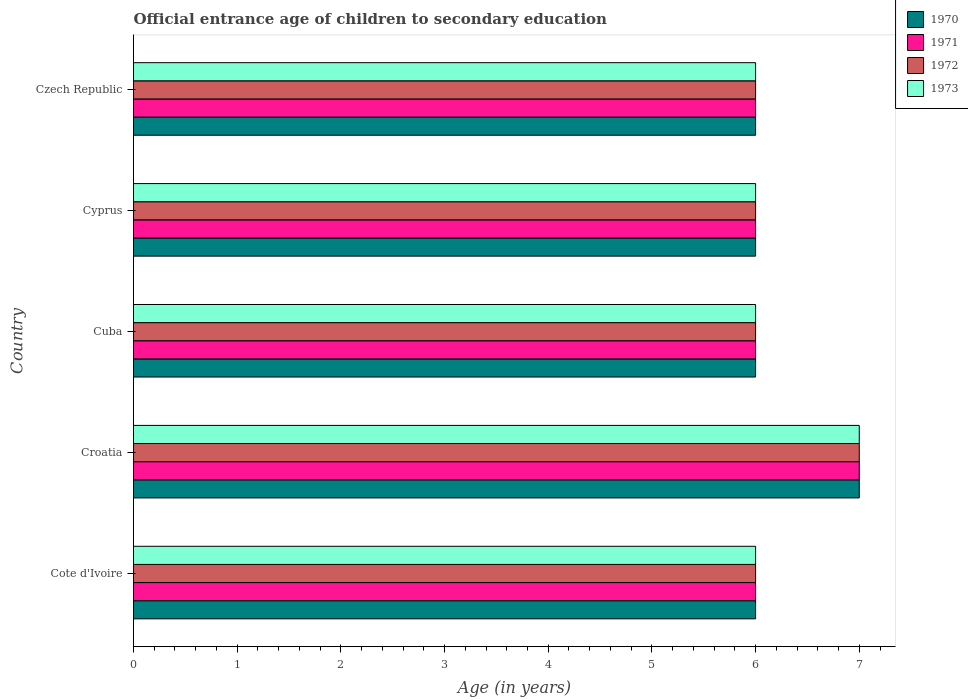Are the number of bars per tick equal to the number of legend labels?
Provide a short and direct response. Yes. Are the number of bars on each tick of the Y-axis equal?
Keep it short and to the point. Yes. What is the label of the 4th group of bars from the top?
Give a very brief answer. Croatia. Across all countries, what is the maximum secondary school starting age of children in 1970?
Provide a short and direct response. 7. In which country was the secondary school starting age of children in 1970 maximum?
Ensure brevity in your answer.  Croatia. In which country was the secondary school starting age of children in 1972 minimum?
Give a very brief answer. Cote d'Ivoire. What is the difference between the secondary school starting age of children in 1973 and secondary school starting age of children in 1971 in Cote d'Ivoire?
Your answer should be very brief. 0. In how many countries, is the secondary school starting age of children in 1972 greater than 1.4 years?
Make the answer very short. 5. What is the ratio of the secondary school starting age of children in 1971 in Cuba to that in Cyprus?
Keep it short and to the point. 1. Is the difference between the secondary school starting age of children in 1973 in Cote d'Ivoire and Croatia greater than the difference between the secondary school starting age of children in 1971 in Cote d'Ivoire and Croatia?
Make the answer very short. No. In how many countries, is the secondary school starting age of children in 1970 greater than the average secondary school starting age of children in 1970 taken over all countries?
Ensure brevity in your answer.  1. Is it the case that in every country, the sum of the secondary school starting age of children in 1973 and secondary school starting age of children in 1970 is greater than the sum of secondary school starting age of children in 1971 and secondary school starting age of children in 1972?
Offer a terse response. No. How many bars are there?
Keep it short and to the point. 20. Are all the bars in the graph horizontal?
Offer a very short reply. Yes. How many countries are there in the graph?
Your answer should be very brief. 5. Are the values on the major ticks of X-axis written in scientific E-notation?
Your answer should be very brief. No. Does the graph contain grids?
Ensure brevity in your answer.  No. How are the legend labels stacked?
Give a very brief answer. Vertical. What is the title of the graph?
Make the answer very short. Official entrance age of children to secondary education. Does "2002" appear as one of the legend labels in the graph?
Keep it short and to the point. No. What is the label or title of the X-axis?
Keep it short and to the point. Age (in years). What is the label or title of the Y-axis?
Your response must be concise. Country. What is the Age (in years) of 1972 in Cote d'Ivoire?
Ensure brevity in your answer.  6. What is the Age (in years) of 1973 in Cote d'Ivoire?
Offer a terse response. 6. What is the Age (in years) of 1970 in Cuba?
Your answer should be compact. 6. What is the Age (in years) in 1971 in Cuba?
Your answer should be very brief. 6. What is the Age (in years) in 1972 in Cuba?
Your answer should be very brief. 6. What is the Age (in years) in 1972 in Cyprus?
Offer a terse response. 6. Across all countries, what is the maximum Age (in years) of 1972?
Provide a succinct answer. 7. Across all countries, what is the minimum Age (in years) of 1972?
Provide a succinct answer. 6. Across all countries, what is the minimum Age (in years) in 1973?
Make the answer very short. 6. What is the total Age (in years) of 1970 in the graph?
Keep it short and to the point. 31. What is the total Age (in years) of 1972 in the graph?
Your response must be concise. 31. What is the total Age (in years) of 1973 in the graph?
Provide a succinct answer. 31. What is the difference between the Age (in years) of 1970 in Cote d'Ivoire and that in Croatia?
Your response must be concise. -1. What is the difference between the Age (in years) in 1971 in Cote d'Ivoire and that in Croatia?
Offer a terse response. -1. What is the difference between the Age (in years) in 1970 in Cote d'Ivoire and that in Cuba?
Provide a short and direct response. 0. What is the difference between the Age (in years) in 1973 in Cote d'Ivoire and that in Cuba?
Keep it short and to the point. 0. What is the difference between the Age (in years) in 1970 in Cote d'Ivoire and that in Cyprus?
Make the answer very short. 0. What is the difference between the Age (in years) in 1971 in Cote d'Ivoire and that in Cyprus?
Make the answer very short. 0. What is the difference between the Age (in years) in 1972 in Cote d'Ivoire and that in Cyprus?
Make the answer very short. 0. What is the difference between the Age (in years) of 1970 in Cote d'Ivoire and that in Czech Republic?
Offer a terse response. 0. What is the difference between the Age (in years) in 1973 in Cote d'Ivoire and that in Czech Republic?
Your answer should be compact. 0. What is the difference between the Age (in years) of 1973 in Croatia and that in Cuba?
Give a very brief answer. 1. What is the difference between the Age (in years) in 1970 in Croatia and that in Cyprus?
Your answer should be compact. 1. What is the difference between the Age (in years) of 1972 in Croatia and that in Cyprus?
Your answer should be compact. 1. What is the difference between the Age (in years) in 1973 in Croatia and that in Cyprus?
Ensure brevity in your answer.  1. What is the difference between the Age (in years) of 1972 in Croatia and that in Czech Republic?
Provide a succinct answer. 1. What is the difference between the Age (in years) of 1972 in Cuba and that in Cyprus?
Offer a terse response. 0. What is the difference between the Age (in years) in 1970 in Cuba and that in Czech Republic?
Offer a very short reply. 0. What is the difference between the Age (in years) of 1971 in Cuba and that in Czech Republic?
Give a very brief answer. 0. What is the difference between the Age (in years) in 1973 in Cuba and that in Czech Republic?
Provide a short and direct response. 0. What is the difference between the Age (in years) in 1972 in Cyprus and that in Czech Republic?
Keep it short and to the point. 0. What is the difference between the Age (in years) in 1973 in Cyprus and that in Czech Republic?
Offer a terse response. 0. What is the difference between the Age (in years) of 1970 in Cote d'Ivoire and the Age (in years) of 1972 in Croatia?
Provide a short and direct response. -1. What is the difference between the Age (in years) in 1970 in Cote d'Ivoire and the Age (in years) in 1971 in Cuba?
Offer a terse response. 0. What is the difference between the Age (in years) of 1971 in Cote d'Ivoire and the Age (in years) of 1972 in Cuba?
Your answer should be compact. 0. What is the difference between the Age (in years) in 1972 in Cote d'Ivoire and the Age (in years) in 1973 in Cuba?
Your answer should be compact. 0. What is the difference between the Age (in years) of 1970 in Cote d'Ivoire and the Age (in years) of 1972 in Cyprus?
Offer a very short reply. 0. What is the difference between the Age (in years) in 1970 in Cote d'Ivoire and the Age (in years) in 1973 in Cyprus?
Your response must be concise. 0. What is the difference between the Age (in years) of 1971 in Cote d'Ivoire and the Age (in years) of 1973 in Cyprus?
Give a very brief answer. 0. What is the difference between the Age (in years) in 1972 in Cote d'Ivoire and the Age (in years) in 1973 in Cyprus?
Offer a very short reply. 0. What is the difference between the Age (in years) in 1972 in Cote d'Ivoire and the Age (in years) in 1973 in Czech Republic?
Offer a very short reply. 0. What is the difference between the Age (in years) in 1971 in Croatia and the Age (in years) in 1973 in Cuba?
Your answer should be very brief. 1. What is the difference between the Age (in years) of 1972 in Croatia and the Age (in years) of 1973 in Cuba?
Your response must be concise. 1. What is the difference between the Age (in years) of 1971 in Croatia and the Age (in years) of 1972 in Cyprus?
Give a very brief answer. 1. What is the difference between the Age (in years) in 1972 in Croatia and the Age (in years) in 1973 in Cyprus?
Keep it short and to the point. 1. What is the difference between the Age (in years) in 1970 in Croatia and the Age (in years) in 1971 in Czech Republic?
Give a very brief answer. 1. What is the difference between the Age (in years) in 1970 in Croatia and the Age (in years) in 1972 in Czech Republic?
Keep it short and to the point. 1. What is the difference between the Age (in years) of 1970 in Croatia and the Age (in years) of 1973 in Czech Republic?
Offer a very short reply. 1. What is the difference between the Age (in years) of 1971 in Croatia and the Age (in years) of 1972 in Czech Republic?
Keep it short and to the point. 1. What is the difference between the Age (in years) of 1970 in Cuba and the Age (in years) of 1972 in Cyprus?
Your answer should be compact. 0. What is the difference between the Age (in years) of 1970 in Cuba and the Age (in years) of 1973 in Cyprus?
Your answer should be compact. 0. What is the difference between the Age (in years) in 1971 in Cuba and the Age (in years) in 1972 in Cyprus?
Make the answer very short. 0. What is the difference between the Age (in years) of 1971 in Cuba and the Age (in years) of 1973 in Cyprus?
Ensure brevity in your answer.  0. What is the difference between the Age (in years) of 1972 in Cuba and the Age (in years) of 1973 in Cyprus?
Your answer should be very brief. 0. What is the difference between the Age (in years) of 1970 in Cuba and the Age (in years) of 1971 in Czech Republic?
Give a very brief answer. 0. What is the difference between the Age (in years) of 1971 in Cuba and the Age (in years) of 1973 in Czech Republic?
Provide a short and direct response. 0. What is the difference between the Age (in years) of 1972 in Cuba and the Age (in years) of 1973 in Czech Republic?
Keep it short and to the point. 0. What is the difference between the Age (in years) in 1970 in Cyprus and the Age (in years) in 1972 in Czech Republic?
Your answer should be very brief. 0. What is the difference between the Age (in years) in 1970 in Cyprus and the Age (in years) in 1973 in Czech Republic?
Give a very brief answer. 0. What is the difference between the Age (in years) in 1971 in Cyprus and the Age (in years) in 1972 in Czech Republic?
Provide a succinct answer. 0. What is the average Age (in years) in 1971 per country?
Ensure brevity in your answer.  6.2. What is the difference between the Age (in years) in 1970 and Age (in years) in 1973 in Cote d'Ivoire?
Give a very brief answer. 0. What is the difference between the Age (in years) in 1971 and Age (in years) in 1972 in Cote d'Ivoire?
Offer a terse response. 0. What is the difference between the Age (in years) of 1972 and Age (in years) of 1973 in Cote d'Ivoire?
Your answer should be very brief. 0. What is the difference between the Age (in years) of 1970 and Age (in years) of 1972 in Croatia?
Offer a very short reply. 0. What is the difference between the Age (in years) in 1971 and Age (in years) in 1973 in Croatia?
Ensure brevity in your answer.  0. What is the difference between the Age (in years) of 1970 and Age (in years) of 1972 in Cuba?
Your answer should be compact. 0. What is the difference between the Age (in years) of 1971 and Age (in years) of 1972 in Cuba?
Offer a very short reply. 0. What is the difference between the Age (in years) of 1971 and Age (in years) of 1973 in Cuba?
Provide a short and direct response. 0. What is the difference between the Age (in years) in 1970 and Age (in years) in 1972 in Cyprus?
Your response must be concise. 0. What is the difference between the Age (in years) in 1971 and Age (in years) in 1972 in Cyprus?
Offer a terse response. 0. What is the difference between the Age (in years) of 1972 and Age (in years) of 1973 in Czech Republic?
Provide a succinct answer. 0. What is the ratio of the Age (in years) in 1970 in Cote d'Ivoire to that in Croatia?
Your answer should be compact. 0.86. What is the ratio of the Age (in years) of 1972 in Cote d'Ivoire to that in Croatia?
Your answer should be very brief. 0.86. What is the ratio of the Age (in years) of 1971 in Cote d'Ivoire to that in Cuba?
Make the answer very short. 1. What is the ratio of the Age (in years) in 1972 in Cote d'Ivoire to that in Cuba?
Give a very brief answer. 1. What is the ratio of the Age (in years) of 1973 in Cote d'Ivoire to that in Cyprus?
Your answer should be very brief. 1. What is the ratio of the Age (in years) of 1970 in Cote d'Ivoire to that in Czech Republic?
Your answer should be compact. 1. What is the ratio of the Age (in years) in 1971 in Croatia to that in Cuba?
Give a very brief answer. 1.17. What is the ratio of the Age (in years) of 1972 in Croatia to that in Cuba?
Your response must be concise. 1.17. What is the ratio of the Age (in years) in 1973 in Croatia to that in Cuba?
Provide a short and direct response. 1.17. What is the ratio of the Age (in years) of 1971 in Croatia to that in Cyprus?
Provide a short and direct response. 1.17. What is the ratio of the Age (in years) of 1973 in Croatia to that in Cyprus?
Make the answer very short. 1.17. What is the ratio of the Age (in years) in 1970 in Croatia to that in Czech Republic?
Make the answer very short. 1.17. What is the ratio of the Age (in years) in 1971 in Croatia to that in Czech Republic?
Provide a short and direct response. 1.17. What is the ratio of the Age (in years) of 1970 in Cuba to that in Cyprus?
Provide a short and direct response. 1. What is the ratio of the Age (in years) of 1971 in Cuba to that in Cyprus?
Make the answer very short. 1. What is the ratio of the Age (in years) in 1972 in Cuba to that in Czech Republic?
Give a very brief answer. 1. What is the ratio of the Age (in years) of 1970 in Cyprus to that in Czech Republic?
Offer a terse response. 1. What is the ratio of the Age (in years) of 1971 in Cyprus to that in Czech Republic?
Your response must be concise. 1. What is the difference between the highest and the second highest Age (in years) of 1971?
Provide a short and direct response. 1. What is the difference between the highest and the second highest Age (in years) of 1972?
Offer a very short reply. 1. What is the difference between the highest and the lowest Age (in years) in 1972?
Your answer should be compact. 1. 